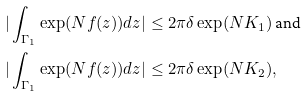Convert formula to latex. <formula><loc_0><loc_0><loc_500><loc_500>| \int _ { \Gamma _ { 1 } } \exp ( N f ( z ) ) d z | & \leq 2 \pi \delta \exp ( N K _ { 1 } ) \text { and } \\ | \int _ { \Gamma _ { 1 } } \exp ( N f ( z ) ) d z | & \leq 2 \pi \delta \exp ( N K _ { 2 } ) ,</formula> 